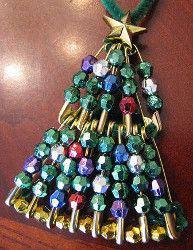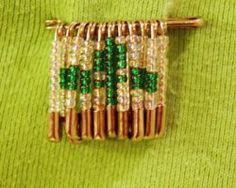The first image is the image on the left, the second image is the image on the right. Given the left and right images, does the statement "The pin in the image on the left looks like an American flag." hold true? Answer yes or no. No. The first image is the image on the left, the second image is the image on the right. Examine the images to the left and right. Is the description "Left image includes an item made of beads, shaped like a Christmas tree with a star on top." accurate? Answer yes or no. Yes. 